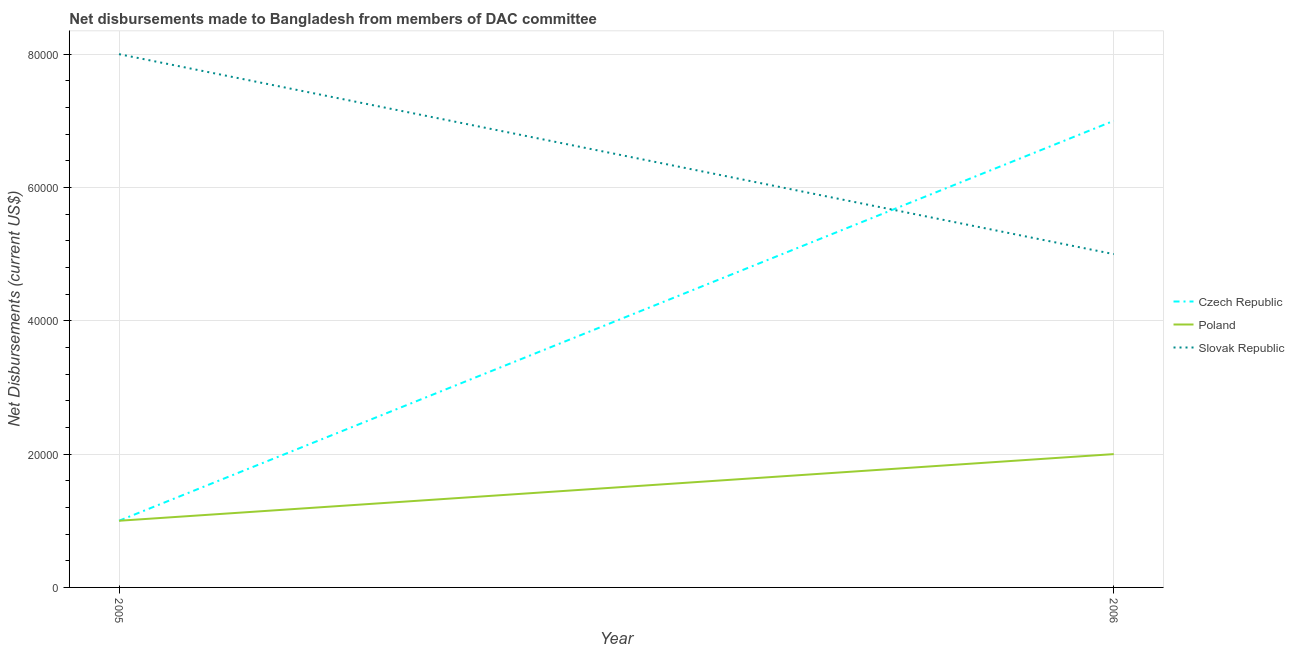How many different coloured lines are there?
Offer a very short reply. 3. Does the line corresponding to net disbursements made by poland intersect with the line corresponding to net disbursements made by slovak republic?
Give a very brief answer. No. What is the net disbursements made by slovak republic in 2006?
Your response must be concise. 5.00e+04. Across all years, what is the maximum net disbursements made by poland?
Offer a very short reply. 2.00e+04. Across all years, what is the minimum net disbursements made by slovak republic?
Your answer should be compact. 5.00e+04. In which year was the net disbursements made by czech republic maximum?
Provide a succinct answer. 2006. In which year was the net disbursements made by slovak republic minimum?
Your answer should be compact. 2006. What is the total net disbursements made by czech republic in the graph?
Give a very brief answer. 8.00e+04. What is the difference between the net disbursements made by poland in 2005 and that in 2006?
Your answer should be compact. -10000. What is the difference between the net disbursements made by slovak republic in 2006 and the net disbursements made by czech republic in 2005?
Your response must be concise. 4.00e+04. What is the average net disbursements made by slovak republic per year?
Make the answer very short. 6.50e+04. In the year 2006, what is the difference between the net disbursements made by poland and net disbursements made by slovak republic?
Offer a terse response. -3.00e+04. In how many years, is the net disbursements made by poland greater than the average net disbursements made by poland taken over all years?
Make the answer very short. 1. Is it the case that in every year, the sum of the net disbursements made by czech republic and net disbursements made by poland is greater than the net disbursements made by slovak republic?
Your answer should be compact. No. Does the net disbursements made by slovak republic monotonically increase over the years?
Make the answer very short. No. Is the net disbursements made by slovak republic strictly greater than the net disbursements made by poland over the years?
Offer a very short reply. Yes. What is the difference between two consecutive major ticks on the Y-axis?
Ensure brevity in your answer.  2.00e+04. Are the values on the major ticks of Y-axis written in scientific E-notation?
Provide a succinct answer. No. Does the graph contain any zero values?
Provide a short and direct response. No. Does the graph contain grids?
Offer a terse response. Yes. How are the legend labels stacked?
Make the answer very short. Vertical. What is the title of the graph?
Provide a succinct answer. Net disbursements made to Bangladesh from members of DAC committee. What is the label or title of the X-axis?
Your answer should be very brief. Year. What is the label or title of the Y-axis?
Your response must be concise. Net Disbursements (current US$). What is the Net Disbursements (current US$) of Czech Republic in 2005?
Ensure brevity in your answer.  10000. What is the Net Disbursements (current US$) in Slovak Republic in 2005?
Offer a terse response. 8.00e+04. What is the Net Disbursements (current US$) of Slovak Republic in 2006?
Keep it short and to the point. 5.00e+04. Across all years, what is the maximum Net Disbursements (current US$) of Czech Republic?
Give a very brief answer. 7.00e+04. Across all years, what is the maximum Net Disbursements (current US$) in Slovak Republic?
Your answer should be compact. 8.00e+04. Across all years, what is the minimum Net Disbursements (current US$) of Czech Republic?
Your answer should be compact. 10000. Across all years, what is the minimum Net Disbursements (current US$) in Poland?
Your response must be concise. 10000. Across all years, what is the minimum Net Disbursements (current US$) in Slovak Republic?
Offer a terse response. 5.00e+04. What is the total Net Disbursements (current US$) of Slovak Republic in the graph?
Your answer should be compact. 1.30e+05. What is the difference between the Net Disbursements (current US$) of Czech Republic in 2005 and that in 2006?
Ensure brevity in your answer.  -6.00e+04. What is the difference between the Net Disbursements (current US$) in Poland in 2005 and that in 2006?
Offer a very short reply. -10000. What is the difference between the Net Disbursements (current US$) in Czech Republic in 2005 and the Net Disbursements (current US$) in Slovak Republic in 2006?
Offer a very short reply. -4.00e+04. What is the difference between the Net Disbursements (current US$) of Poland in 2005 and the Net Disbursements (current US$) of Slovak Republic in 2006?
Give a very brief answer. -4.00e+04. What is the average Net Disbursements (current US$) in Czech Republic per year?
Ensure brevity in your answer.  4.00e+04. What is the average Net Disbursements (current US$) in Poland per year?
Keep it short and to the point. 1.50e+04. What is the average Net Disbursements (current US$) of Slovak Republic per year?
Your answer should be compact. 6.50e+04. In the year 2005, what is the difference between the Net Disbursements (current US$) in Czech Republic and Net Disbursements (current US$) in Poland?
Give a very brief answer. 0. In the year 2005, what is the difference between the Net Disbursements (current US$) in Poland and Net Disbursements (current US$) in Slovak Republic?
Provide a short and direct response. -7.00e+04. In the year 2006, what is the difference between the Net Disbursements (current US$) in Poland and Net Disbursements (current US$) in Slovak Republic?
Your answer should be very brief. -3.00e+04. What is the ratio of the Net Disbursements (current US$) in Czech Republic in 2005 to that in 2006?
Keep it short and to the point. 0.14. What is the ratio of the Net Disbursements (current US$) of Poland in 2005 to that in 2006?
Your response must be concise. 0.5. What is the ratio of the Net Disbursements (current US$) of Slovak Republic in 2005 to that in 2006?
Make the answer very short. 1.6. What is the difference between the highest and the second highest Net Disbursements (current US$) of Poland?
Ensure brevity in your answer.  10000. What is the difference between the highest and the second highest Net Disbursements (current US$) of Slovak Republic?
Keep it short and to the point. 3.00e+04. What is the difference between the highest and the lowest Net Disbursements (current US$) of Czech Republic?
Your answer should be very brief. 6.00e+04. What is the difference between the highest and the lowest Net Disbursements (current US$) in Poland?
Give a very brief answer. 10000. What is the difference between the highest and the lowest Net Disbursements (current US$) of Slovak Republic?
Your answer should be very brief. 3.00e+04. 